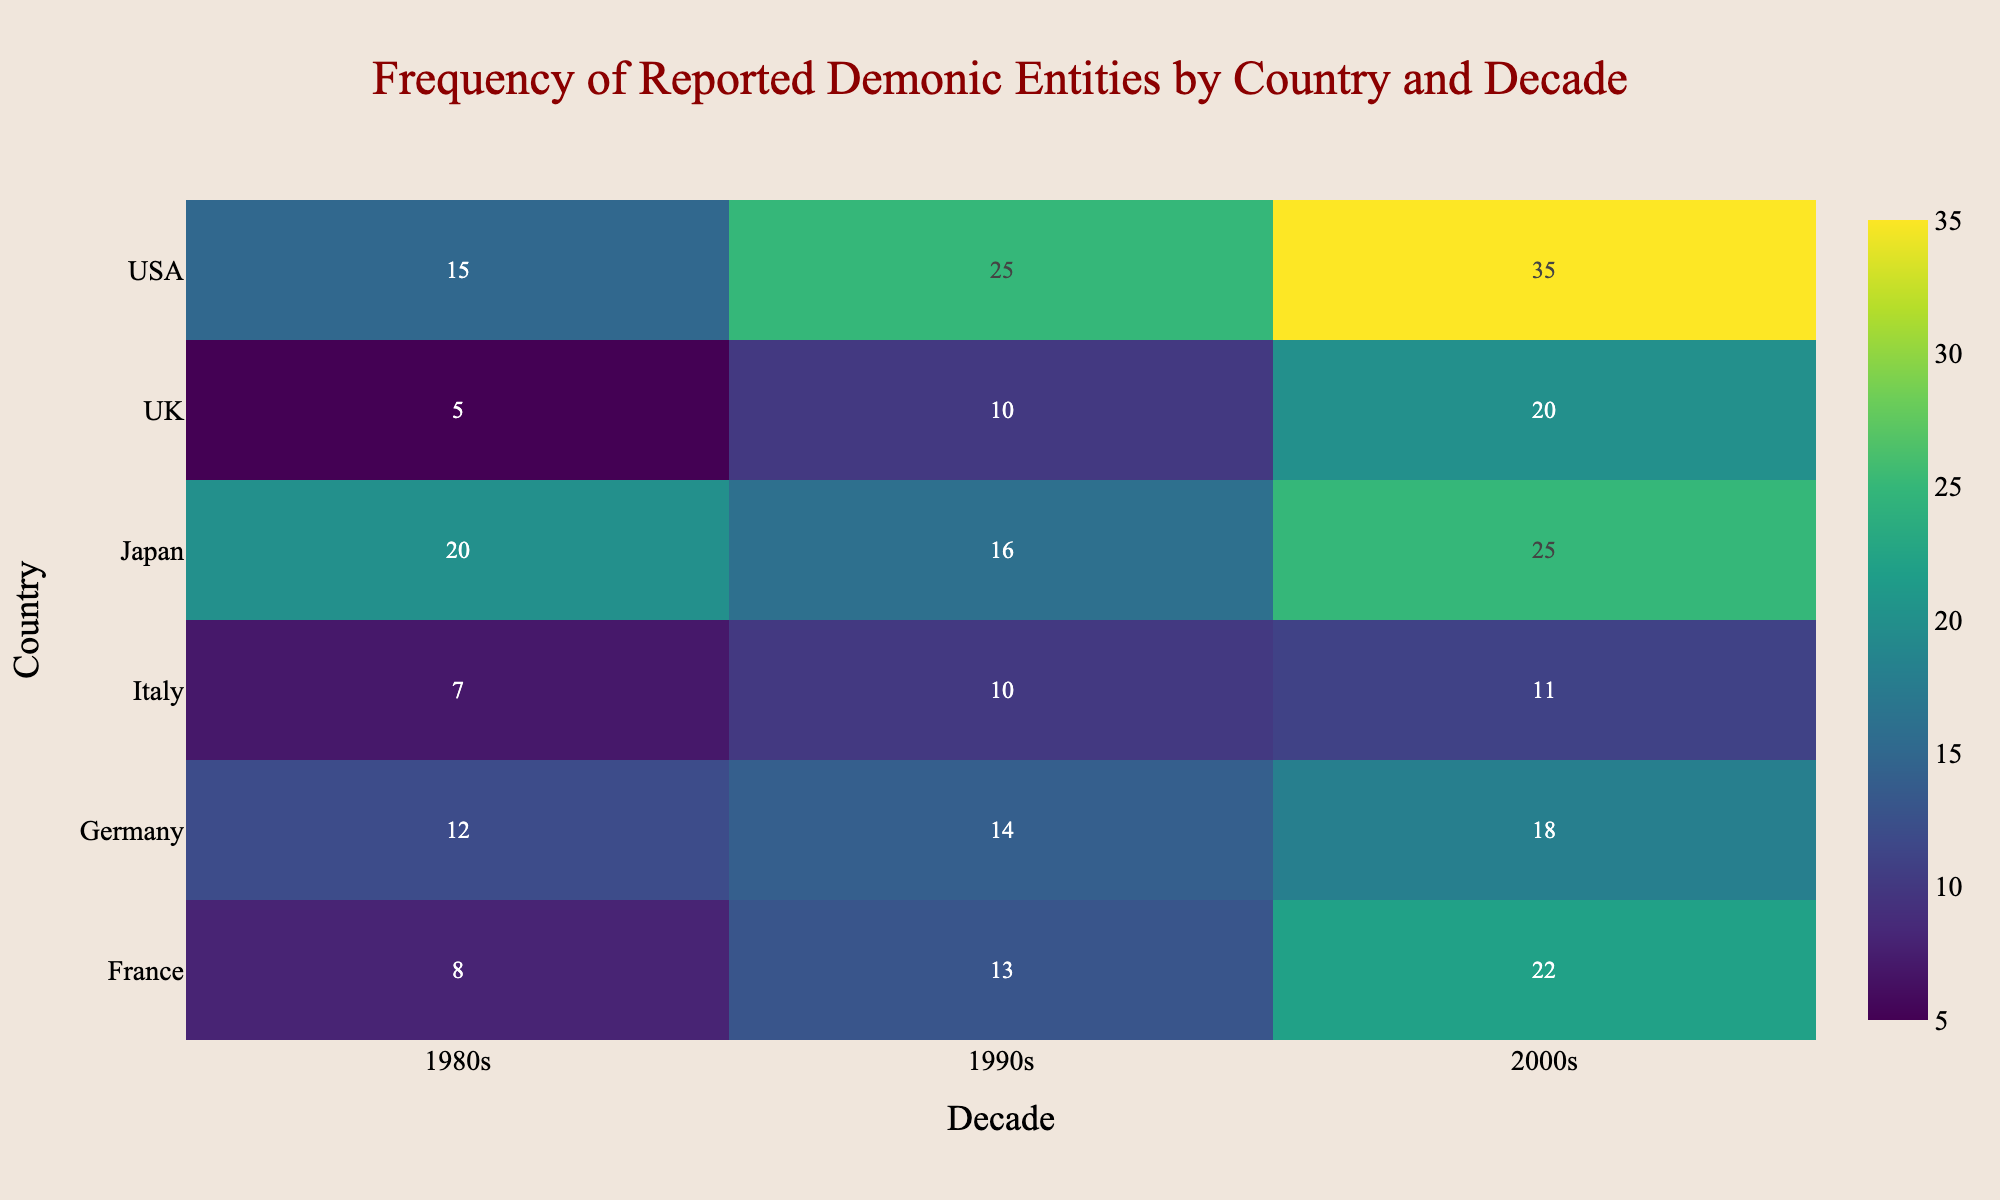What is the title of the figure? The title is usually located at the top center of the figure and gives a summary of what the visualization represents. The title here is "Frequency of Reported Demonic Entities by Country and Decade"
Answer: Frequency of Reported Demonic Entities by Country and Decade Which country reported the highest frequency of demonic entities in the 2000s? To find this, look at the colors or values for the column that represents the 2000s and identify the country with the highest number. The USA has a frequency value of 35 in the 2000s, which is the highest.
Answer: USA What is the total frequency of demonic entities reported in Germany in all decades? Add the frequencies for Germany across all decades: 12 (1980s) + 14 (1990s) + 18 (2000s) = 44
Answer: 44 Which country had the most changes in types of demonic entities reported over the three decades? Compare the types of demonic entities reported in each decade for each country. Japan had Yurei in the 1980s, Oni in the 1990s, and Kuchisake-onna in the 2000s, showing the most changes in types.
Answer: Japan In which decade did the UK report the highest frequency of demonic entities? Compare the frequency values for the UK across all decades. The highest frequency is in the 2000s with a value of 20.
Answer: 2000s Which countries reported Poltergeists, and in which decades? Look for the term Poltergeist and note the corresponding countries and decades: USA in 1990s, UK in 2000s, Germany in 1990s, France in 1990s, and Italy in 1990s.
Answer: USA (1990s), UK (2000s), Germany (1990s), France (1990s), Italy (1990s) What is the average frequency of reported demonic entities in the 1990s across all countries? Sum the frequencies for all countries in the 1990s and then divide by the number of countries: (25 + 10 + 14 + 13 + 10 + 16) / 6 = 88 / 6 ≈ 14.67
Answer: 14.67 Which country had the lowest frequency of demonic entities reported in the 1980s? Compare the frequency values for all countries in the 1980s. The UK has the lowest frequency with a value of 5.
Answer: UK Between the 1990s and 2000s, which country showed the greatest increase in the frequency of demonic entities reported? Calculate the difference between the frequencies for each country between the 1990s and 2000s and identify the largest increase. USA: 35 - 25 = 10, UK: 20 - 10 = 10, Germany: 18 - 14 = 4, France: 22 - 13 = 9, Italy: 11 - 10 = 1, Japan: 25 - 16 = 9. USA and UK both had the greatest increase of 10.
Answer: USA, UK What type of demonic entity was most frequently reported in France in the 2000s? Identify the frequency value for France in the 2000s and match it with the corresponding demonic entity. Demonic Possession has the highest frequency of 22.
Answer: Demonic Possession 